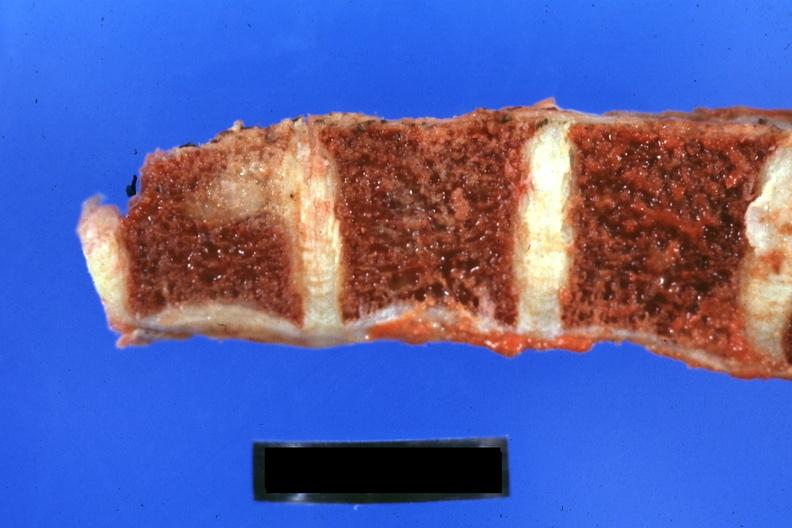s joints present?
Answer the question using a single word or phrase. Yes 